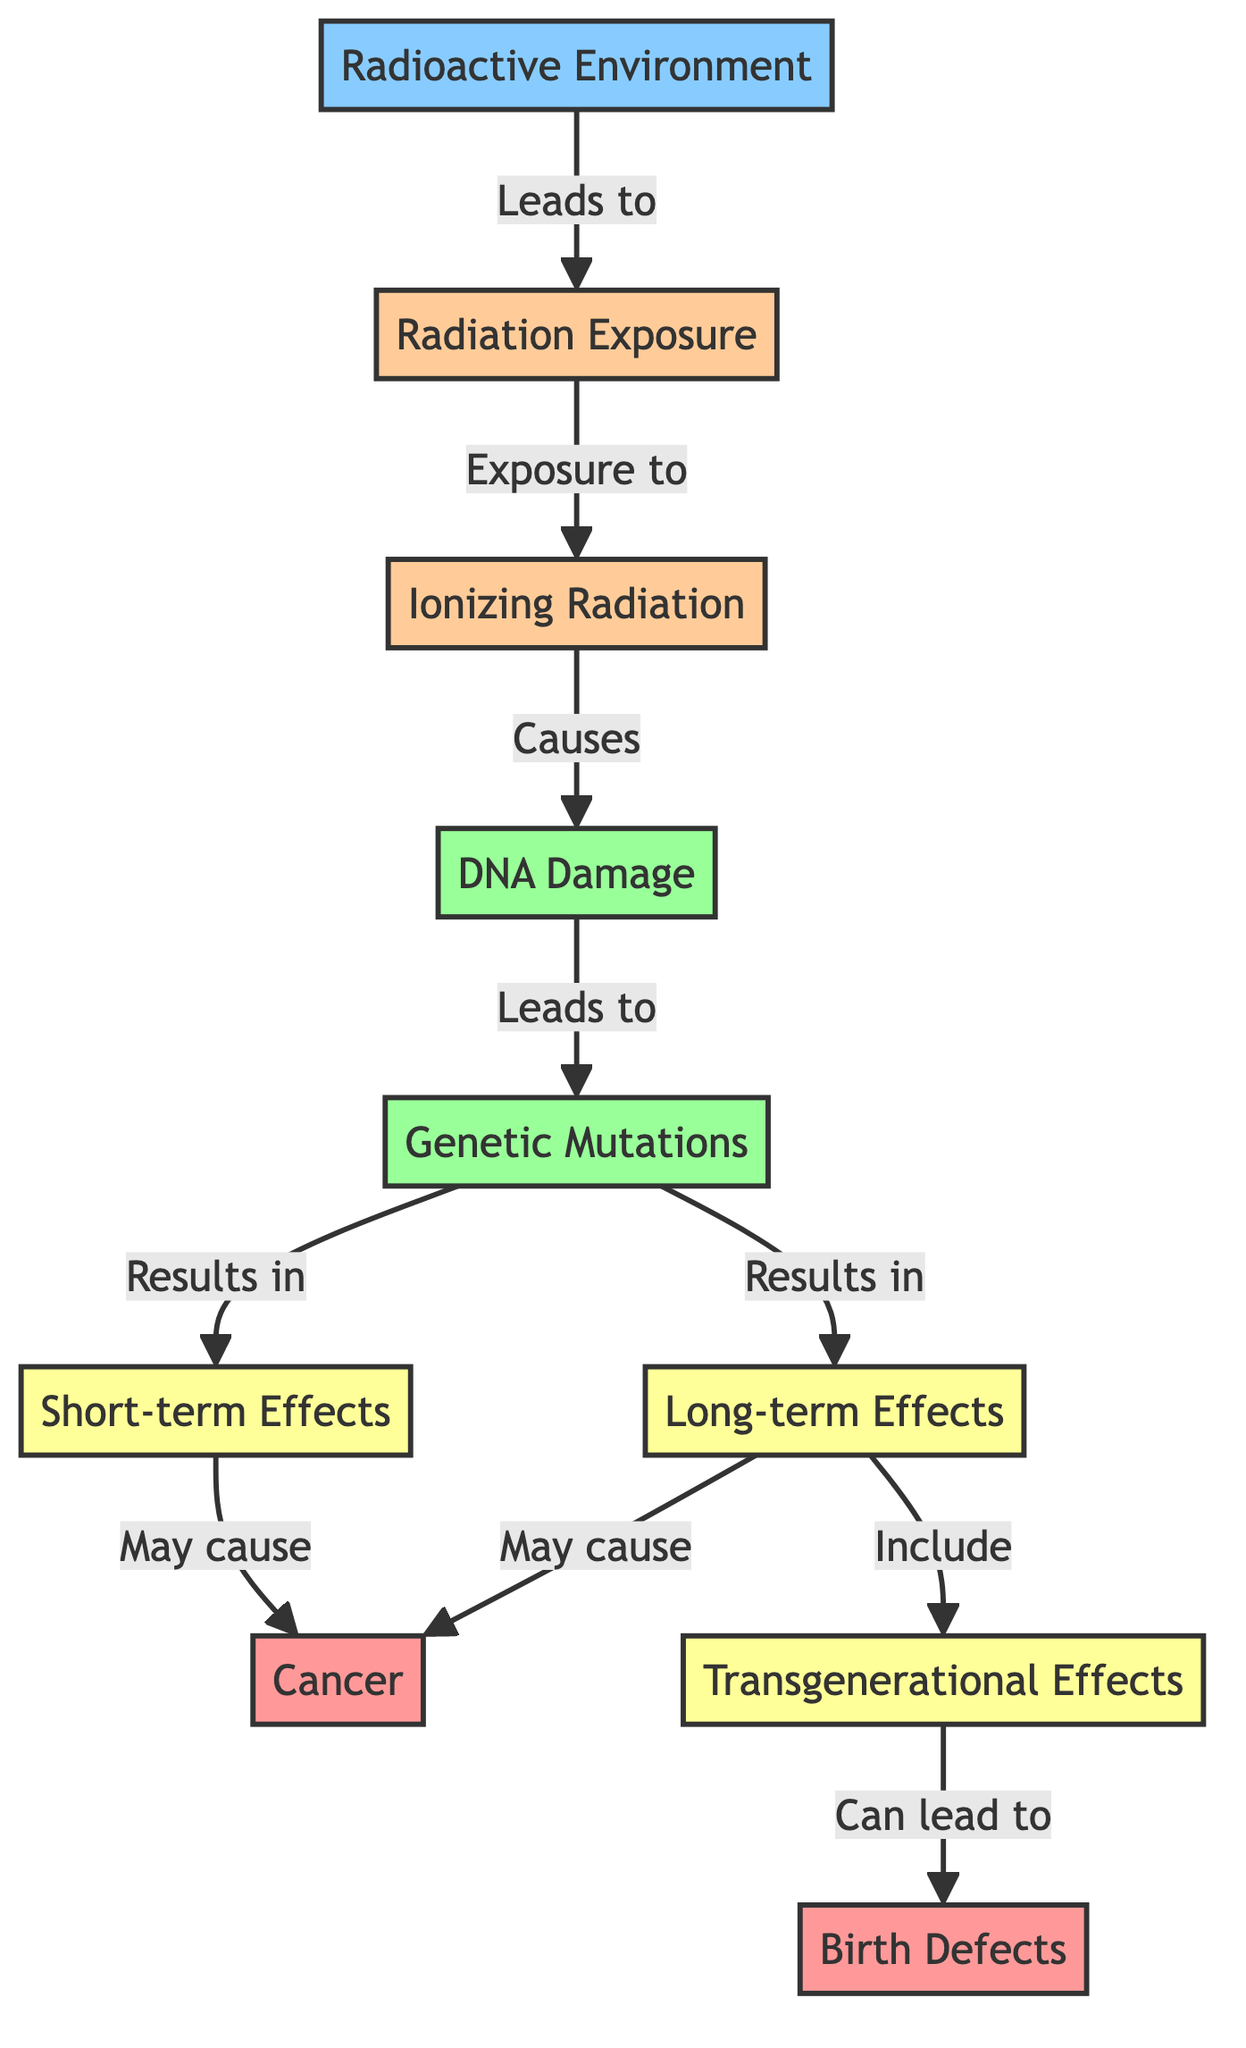What leads to radiation exposure? The diagram indicates that a "Radioactive Environment" leads to "Radiation Exposure." Therefore, by tracing the flow from the "Radioactive Environment" node, we can determine that it is the initial factor causing radiation exposure.
Answer: Radioactive Environment How many types of effects are mentioned? The diagram shows multiple effects resulting from genetic mutations: "Short-term Effects," "Long-term Effects," and "Transgenerational Effects." Counting these, there are three distinct types of effects.
Answer: 3 Which factor causes DNA damage? According to the diagram, "Ionizing Radiation" directly causes "DNA Damage." By following the arrows from "Radiation Exposure" to "Ionizing Radiation" and then to "DNA Damage," we can confirm this causal relationship.
Answer: Ionizing Radiation What results from mutations? The diagram illustrates that mutations result in "Short-term Effects" and "Long-term Effects." By tracing these connections from the "Genetic Mutations" node, we find that both types of effects stem directly from mutations.
Answer: Short-term Effects and Long-term Effects What may cancer be caused by? The diagram indicates that both "Short-term Effects" and "Long-term Effects" may cause "Cancer." To find this answer, we look at the arrows leading from both effects to the cancer node, establishing that either can be a cause.
Answer: Short-term Effects and Long-term Effects What can transgenerational effects lead to? The diagram states that "Transgenerational Effects" can lead to "Birth Defects." By following the path from transgenerational effects, we can see that it has a direct consequence on birth defects.
Answer: Birth Defects Which environmental factor is the starting point of the diagram? By analyzing the flowchart, we see that the "Radioactive Environment" is the first node listed, making it the starting point of the entire process outlined in the diagram.
Answer: Radioactive Environment What connects DNA damage to genetic mutations? The diagram shows a direct arrow from "DNA Damage" to "Genetic Mutations," indicating that DNA damage leads to mutations. This relationship can be found within the pathway depicted in the diagram.
Answer: DNA Damage How are birth defects classified in this context? In the diagram, "Birth Defects" are categorized under "Consequences," which connects to "Transgenerational Effects." Therefore, they are classified as a consequence of the mutations leading back to transgenerational impacts.
Answer: Consequences 